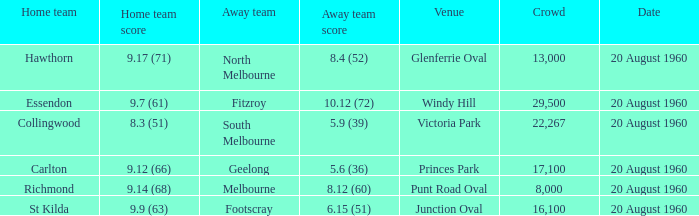What is the crowd size of the game when Fitzroy is the away team? 1.0. 